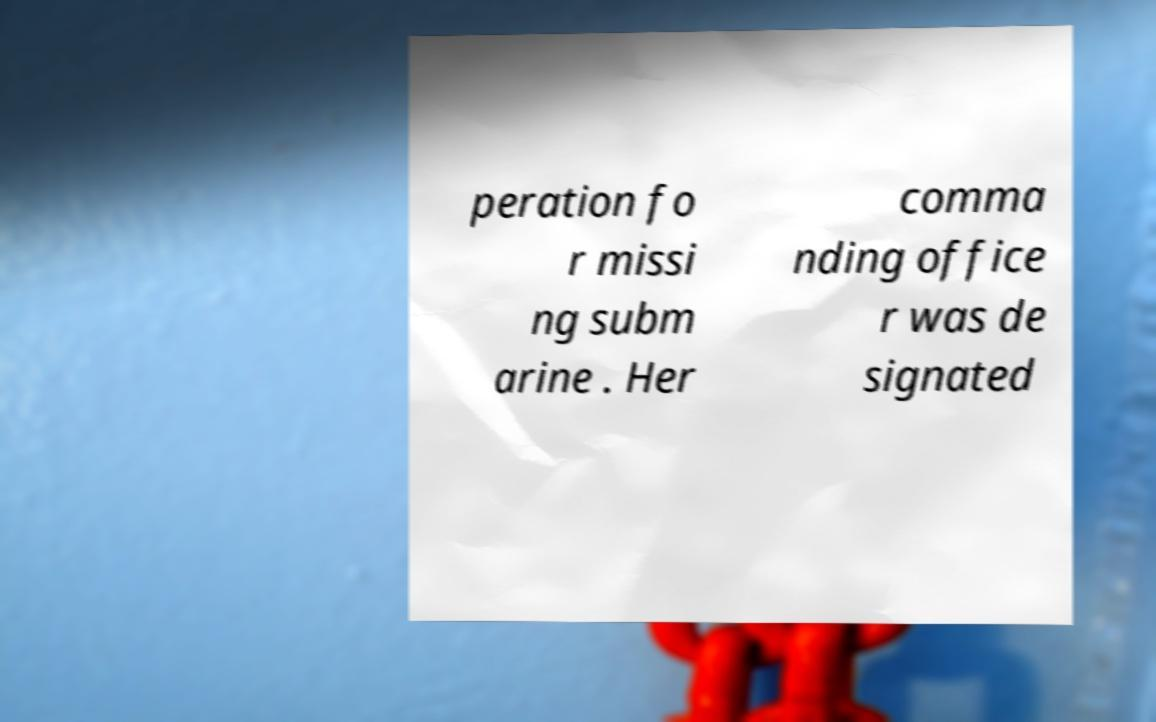Can you accurately transcribe the text from the provided image for me? peration fo r missi ng subm arine . Her comma nding office r was de signated 